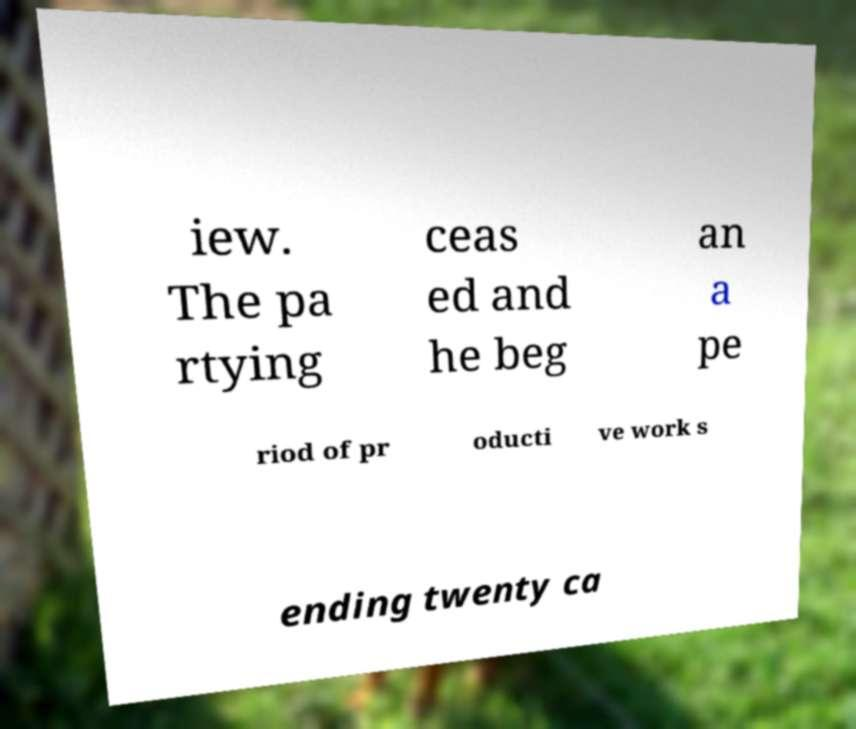For documentation purposes, I need the text within this image transcribed. Could you provide that? iew. The pa rtying ceas ed and he beg an a pe riod of pr oducti ve work s ending twenty ca 